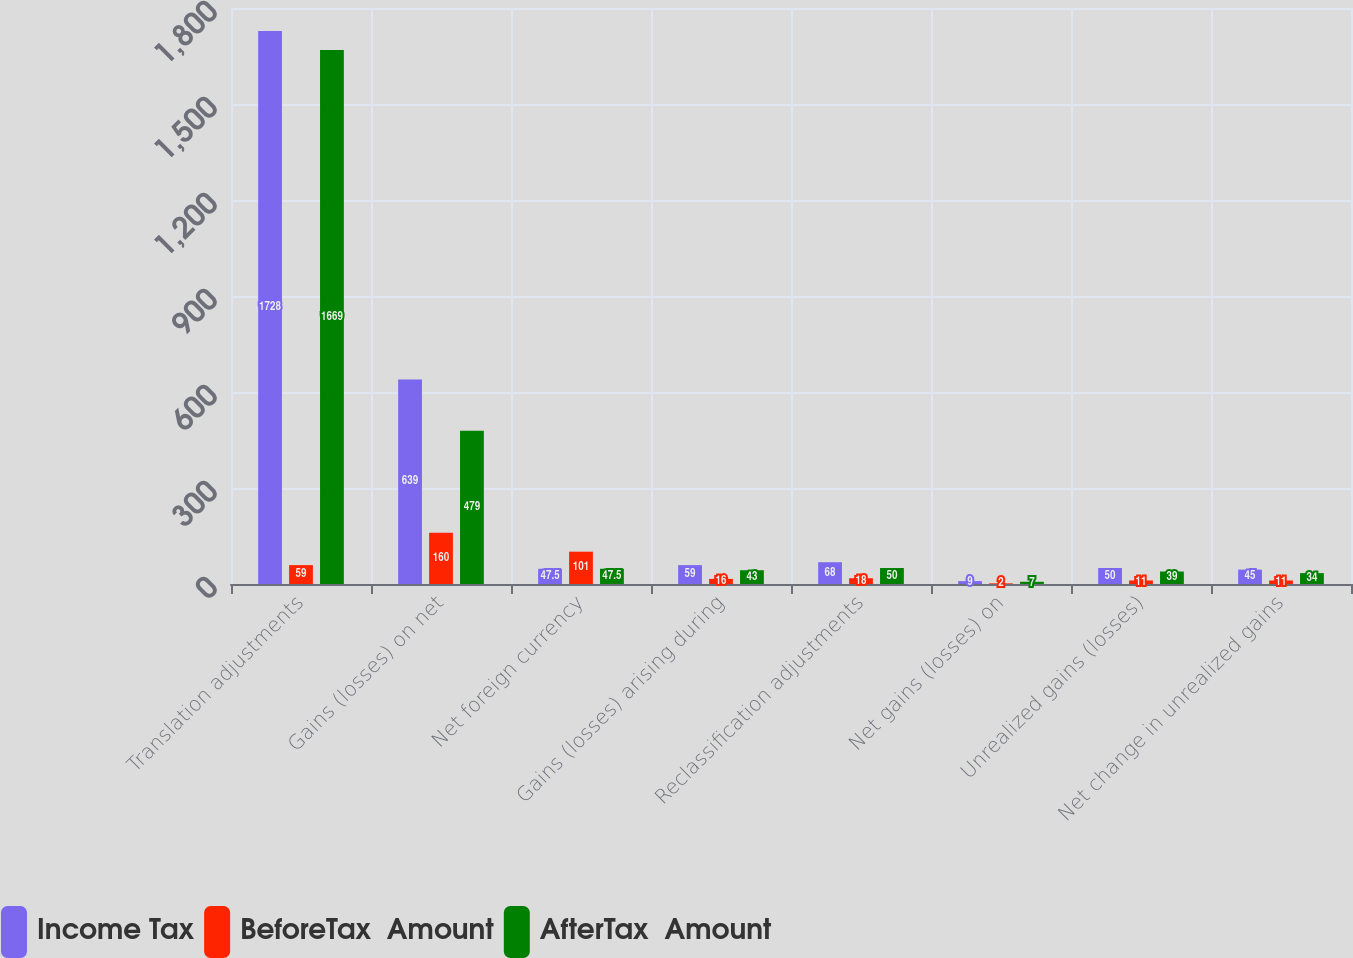Convert chart to OTSL. <chart><loc_0><loc_0><loc_500><loc_500><stacked_bar_chart><ecel><fcel>Translation adjustments<fcel>Gains (losses) on net<fcel>Net foreign currency<fcel>Gains (losses) arising during<fcel>Reclassification adjustments<fcel>Net gains (losses) on<fcel>Unrealized gains (losses)<fcel>Net change in unrealized gains<nl><fcel>Income Tax<fcel>1728<fcel>639<fcel>47.5<fcel>59<fcel>68<fcel>9<fcel>50<fcel>45<nl><fcel>BeforeTax  Amount<fcel>59<fcel>160<fcel>101<fcel>16<fcel>18<fcel>2<fcel>11<fcel>11<nl><fcel>AfterTax  Amount<fcel>1669<fcel>479<fcel>47.5<fcel>43<fcel>50<fcel>7<fcel>39<fcel>34<nl></chart> 